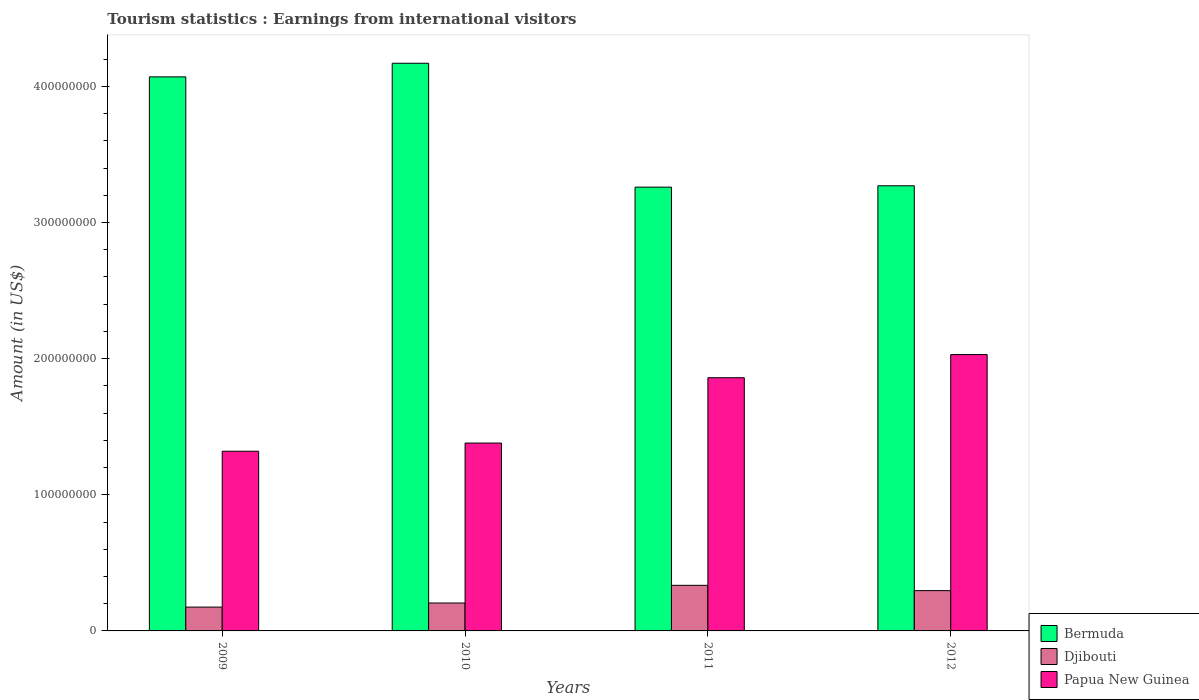How many groups of bars are there?
Provide a succinct answer. 4. Are the number of bars per tick equal to the number of legend labels?
Provide a succinct answer. Yes. Are the number of bars on each tick of the X-axis equal?
Your answer should be very brief. Yes. What is the label of the 4th group of bars from the left?
Offer a terse response. 2012. What is the earnings from international visitors in Papua New Guinea in 2011?
Provide a short and direct response. 1.86e+08. Across all years, what is the maximum earnings from international visitors in Bermuda?
Provide a short and direct response. 4.17e+08. Across all years, what is the minimum earnings from international visitors in Papua New Guinea?
Ensure brevity in your answer.  1.32e+08. In which year was the earnings from international visitors in Djibouti minimum?
Make the answer very short. 2009. What is the total earnings from international visitors in Bermuda in the graph?
Offer a very short reply. 1.48e+09. What is the difference between the earnings from international visitors in Papua New Guinea in 2011 and that in 2012?
Provide a short and direct response. -1.70e+07. What is the difference between the earnings from international visitors in Papua New Guinea in 2011 and the earnings from international visitors in Djibouti in 2010?
Keep it short and to the point. 1.66e+08. What is the average earnings from international visitors in Djibouti per year?
Give a very brief answer. 2.53e+07. In the year 2011, what is the difference between the earnings from international visitors in Papua New Guinea and earnings from international visitors in Djibouti?
Offer a very short reply. 1.52e+08. In how many years, is the earnings from international visitors in Bermuda greater than 40000000 US$?
Offer a very short reply. 4. What is the ratio of the earnings from international visitors in Bermuda in 2009 to that in 2010?
Provide a short and direct response. 0.98. Is the earnings from international visitors in Papua New Guinea in 2010 less than that in 2012?
Ensure brevity in your answer.  Yes. What is the difference between the highest and the second highest earnings from international visitors in Papua New Guinea?
Provide a succinct answer. 1.70e+07. What is the difference between the highest and the lowest earnings from international visitors in Bermuda?
Your answer should be very brief. 9.10e+07. In how many years, is the earnings from international visitors in Djibouti greater than the average earnings from international visitors in Djibouti taken over all years?
Offer a terse response. 2. What does the 1st bar from the left in 2010 represents?
Offer a very short reply. Bermuda. What does the 3rd bar from the right in 2009 represents?
Provide a succinct answer. Bermuda. Are all the bars in the graph horizontal?
Offer a terse response. No. Are the values on the major ticks of Y-axis written in scientific E-notation?
Offer a very short reply. No. Does the graph contain any zero values?
Your response must be concise. No. How many legend labels are there?
Your response must be concise. 3. How are the legend labels stacked?
Keep it short and to the point. Vertical. What is the title of the graph?
Your response must be concise. Tourism statistics : Earnings from international visitors. Does "Honduras" appear as one of the legend labels in the graph?
Ensure brevity in your answer.  No. What is the label or title of the X-axis?
Ensure brevity in your answer.  Years. What is the Amount (in US$) of Bermuda in 2009?
Keep it short and to the point. 4.07e+08. What is the Amount (in US$) in Djibouti in 2009?
Provide a short and direct response. 1.75e+07. What is the Amount (in US$) in Papua New Guinea in 2009?
Offer a terse response. 1.32e+08. What is the Amount (in US$) in Bermuda in 2010?
Your response must be concise. 4.17e+08. What is the Amount (in US$) of Djibouti in 2010?
Make the answer very short. 2.05e+07. What is the Amount (in US$) of Papua New Guinea in 2010?
Make the answer very short. 1.38e+08. What is the Amount (in US$) of Bermuda in 2011?
Ensure brevity in your answer.  3.26e+08. What is the Amount (in US$) in Djibouti in 2011?
Ensure brevity in your answer.  3.35e+07. What is the Amount (in US$) in Papua New Guinea in 2011?
Provide a short and direct response. 1.86e+08. What is the Amount (in US$) of Bermuda in 2012?
Make the answer very short. 3.27e+08. What is the Amount (in US$) of Djibouti in 2012?
Offer a very short reply. 2.96e+07. What is the Amount (in US$) in Papua New Guinea in 2012?
Ensure brevity in your answer.  2.03e+08. Across all years, what is the maximum Amount (in US$) of Bermuda?
Give a very brief answer. 4.17e+08. Across all years, what is the maximum Amount (in US$) of Djibouti?
Provide a succinct answer. 3.35e+07. Across all years, what is the maximum Amount (in US$) of Papua New Guinea?
Provide a short and direct response. 2.03e+08. Across all years, what is the minimum Amount (in US$) of Bermuda?
Ensure brevity in your answer.  3.26e+08. Across all years, what is the minimum Amount (in US$) of Djibouti?
Ensure brevity in your answer.  1.75e+07. Across all years, what is the minimum Amount (in US$) in Papua New Guinea?
Ensure brevity in your answer.  1.32e+08. What is the total Amount (in US$) in Bermuda in the graph?
Provide a succinct answer. 1.48e+09. What is the total Amount (in US$) in Djibouti in the graph?
Provide a succinct answer. 1.01e+08. What is the total Amount (in US$) in Papua New Guinea in the graph?
Make the answer very short. 6.59e+08. What is the difference between the Amount (in US$) in Bermuda in 2009 and that in 2010?
Make the answer very short. -1.00e+07. What is the difference between the Amount (in US$) in Papua New Guinea in 2009 and that in 2010?
Offer a very short reply. -6.00e+06. What is the difference between the Amount (in US$) in Bermuda in 2009 and that in 2011?
Provide a succinct answer. 8.10e+07. What is the difference between the Amount (in US$) in Djibouti in 2009 and that in 2011?
Offer a very short reply. -1.60e+07. What is the difference between the Amount (in US$) in Papua New Guinea in 2009 and that in 2011?
Make the answer very short. -5.40e+07. What is the difference between the Amount (in US$) of Bermuda in 2009 and that in 2012?
Provide a short and direct response. 8.00e+07. What is the difference between the Amount (in US$) of Djibouti in 2009 and that in 2012?
Provide a succinct answer. -1.21e+07. What is the difference between the Amount (in US$) in Papua New Guinea in 2009 and that in 2012?
Your answer should be compact. -7.10e+07. What is the difference between the Amount (in US$) in Bermuda in 2010 and that in 2011?
Keep it short and to the point. 9.10e+07. What is the difference between the Amount (in US$) in Djibouti in 2010 and that in 2011?
Your response must be concise. -1.30e+07. What is the difference between the Amount (in US$) in Papua New Guinea in 2010 and that in 2011?
Make the answer very short. -4.80e+07. What is the difference between the Amount (in US$) of Bermuda in 2010 and that in 2012?
Ensure brevity in your answer.  9.00e+07. What is the difference between the Amount (in US$) in Djibouti in 2010 and that in 2012?
Your answer should be very brief. -9.10e+06. What is the difference between the Amount (in US$) in Papua New Guinea in 2010 and that in 2012?
Offer a very short reply. -6.50e+07. What is the difference between the Amount (in US$) in Djibouti in 2011 and that in 2012?
Your answer should be very brief. 3.90e+06. What is the difference between the Amount (in US$) in Papua New Guinea in 2011 and that in 2012?
Keep it short and to the point. -1.70e+07. What is the difference between the Amount (in US$) in Bermuda in 2009 and the Amount (in US$) in Djibouti in 2010?
Provide a short and direct response. 3.86e+08. What is the difference between the Amount (in US$) of Bermuda in 2009 and the Amount (in US$) of Papua New Guinea in 2010?
Ensure brevity in your answer.  2.69e+08. What is the difference between the Amount (in US$) of Djibouti in 2009 and the Amount (in US$) of Papua New Guinea in 2010?
Your answer should be very brief. -1.20e+08. What is the difference between the Amount (in US$) of Bermuda in 2009 and the Amount (in US$) of Djibouti in 2011?
Give a very brief answer. 3.74e+08. What is the difference between the Amount (in US$) in Bermuda in 2009 and the Amount (in US$) in Papua New Guinea in 2011?
Your response must be concise. 2.21e+08. What is the difference between the Amount (in US$) in Djibouti in 2009 and the Amount (in US$) in Papua New Guinea in 2011?
Ensure brevity in your answer.  -1.68e+08. What is the difference between the Amount (in US$) of Bermuda in 2009 and the Amount (in US$) of Djibouti in 2012?
Provide a succinct answer. 3.77e+08. What is the difference between the Amount (in US$) of Bermuda in 2009 and the Amount (in US$) of Papua New Guinea in 2012?
Give a very brief answer. 2.04e+08. What is the difference between the Amount (in US$) of Djibouti in 2009 and the Amount (in US$) of Papua New Guinea in 2012?
Offer a terse response. -1.86e+08. What is the difference between the Amount (in US$) of Bermuda in 2010 and the Amount (in US$) of Djibouti in 2011?
Your answer should be very brief. 3.84e+08. What is the difference between the Amount (in US$) in Bermuda in 2010 and the Amount (in US$) in Papua New Guinea in 2011?
Ensure brevity in your answer.  2.31e+08. What is the difference between the Amount (in US$) of Djibouti in 2010 and the Amount (in US$) of Papua New Guinea in 2011?
Ensure brevity in your answer.  -1.66e+08. What is the difference between the Amount (in US$) in Bermuda in 2010 and the Amount (in US$) in Djibouti in 2012?
Offer a very short reply. 3.87e+08. What is the difference between the Amount (in US$) in Bermuda in 2010 and the Amount (in US$) in Papua New Guinea in 2012?
Make the answer very short. 2.14e+08. What is the difference between the Amount (in US$) in Djibouti in 2010 and the Amount (in US$) in Papua New Guinea in 2012?
Your answer should be compact. -1.82e+08. What is the difference between the Amount (in US$) of Bermuda in 2011 and the Amount (in US$) of Djibouti in 2012?
Ensure brevity in your answer.  2.96e+08. What is the difference between the Amount (in US$) of Bermuda in 2011 and the Amount (in US$) of Papua New Guinea in 2012?
Give a very brief answer. 1.23e+08. What is the difference between the Amount (in US$) of Djibouti in 2011 and the Amount (in US$) of Papua New Guinea in 2012?
Offer a very short reply. -1.70e+08. What is the average Amount (in US$) in Bermuda per year?
Your answer should be very brief. 3.69e+08. What is the average Amount (in US$) of Djibouti per year?
Offer a terse response. 2.53e+07. What is the average Amount (in US$) of Papua New Guinea per year?
Your response must be concise. 1.65e+08. In the year 2009, what is the difference between the Amount (in US$) of Bermuda and Amount (in US$) of Djibouti?
Provide a short and direct response. 3.90e+08. In the year 2009, what is the difference between the Amount (in US$) in Bermuda and Amount (in US$) in Papua New Guinea?
Ensure brevity in your answer.  2.75e+08. In the year 2009, what is the difference between the Amount (in US$) of Djibouti and Amount (in US$) of Papua New Guinea?
Your response must be concise. -1.14e+08. In the year 2010, what is the difference between the Amount (in US$) of Bermuda and Amount (in US$) of Djibouti?
Provide a succinct answer. 3.96e+08. In the year 2010, what is the difference between the Amount (in US$) in Bermuda and Amount (in US$) in Papua New Guinea?
Provide a succinct answer. 2.79e+08. In the year 2010, what is the difference between the Amount (in US$) in Djibouti and Amount (in US$) in Papua New Guinea?
Your response must be concise. -1.18e+08. In the year 2011, what is the difference between the Amount (in US$) in Bermuda and Amount (in US$) in Djibouti?
Your response must be concise. 2.92e+08. In the year 2011, what is the difference between the Amount (in US$) in Bermuda and Amount (in US$) in Papua New Guinea?
Make the answer very short. 1.40e+08. In the year 2011, what is the difference between the Amount (in US$) of Djibouti and Amount (in US$) of Papua New Guinea?
Keep it short and to the point. -1.52e+08. In the year 2012, what is the difference between the Amount (in US$) of Bermuda and Amount (in US$) of Djibouti?
Offer a terse response. 2.97e+08. In the year 2012, what is the difference between the Amount (in US$) of Bermuda and Amount (in US$) of Papua New Guinea?
Provide a short and direct response. 1.24e+08. In the year 2012, what is the difference between the Amount (in US$) in Djibouti and Amount (in US$) in Papua New Guinea?
Offer a terse response. -1.73e+08. What is the ratio of the Amount (in US$) in Bermuda in 2009 to that in 2010?
Make the answer very short. 0.98. What is the ratio of the Amount (in US$) of Djibouti in 2009 to that in 2010?
Your answer should be very brief. 0.85. What is the ratio of the Amount (in US$) of Papua New Guinea in 2009 to that in 2010?
Your answer should be compact. 0.96. What is the ratio of the Amount (in US$) of Bermuda in 2009 to that in 2011?
Provide a short and direct response. 1.25. What is the ratio of the Amount (in US$) in Djibouti in 2009 to that in 2011?
Keep it short and to the point. 0.52. What is the ratio of the Amount (in US$) in Papua New Guinea in 2009 to that in 2011?
Keep it short and to the point. 0.71. What is the ratio of the Amount (in US$) in Bermuda in 2009 to that in 2012?
Offer a very short reply. 1.24. What is the ratio of the Amount (in US$) of Djibouti in 2009 to that in 2012?
Your answer should be compact. 0.59. What is the ratio of the Amount (in US$) of Papua New Guinea in 2009 to that in 2012?
Provide a short and direct response. 0.65. What is the ratio of the Amount (in US$) of Bermuda in 2010 to that in 2011?
Provide a short and direct response. 1.28. What is the ratio of the Amount (in US$) of Djibouti in 2010 to that in 2011?
Give a very brief answer. 0.61. What is the ratio of the Amount (in US$) of Papua New Guinea in 2010 to that in 2011?
Your answer should be compact. 0.74. What is the ratio of the Amount (in US$) of Bermuda in 2010 to that in 2012?
Ensure brevity in your answer.  1.28. What is the ratio of the Amount (in US$) in Djibouti in 2010 to that in 2012?
Make the answer very short. 0.69. What is the ratio of the Amount (in US$) of Papua New Guinea in 2010 to that in 2012?
Your answer should be very brief. 0.68. What is the ratio of the Amount (in US$) in Bermuda in 2011 to that in 2012?
Your answer should be very brief. 1. What is the ratio of the Amount (in US$) of Djibouti in 2011 to that in 2012?
Ensure brevity in your answer.  1.13. What is the ratio of the Amount (in US$) of Papua New Guinea in 2011 to that in 2012?
Offer a very short reply. 0.92. What is the difference between the highest and the second highest Amount (in US$) of Djibouti?
Your answer should be compact. 3.90e+06. What is the difference between the highest and the second highest Amount (in US$) in Papua New Guinea?
Your answer should be very brief. 1.70e+07. What is the difference between the highest and the lowest Amount (in US$) of Bermuda?
Your answer should be compact. 9.10e+07. What is the difference between the highest and the lowest Amount (in US$) of Djibouti?
Ensure brevity in your answer.  1.60e+07. What is the difference between the highest and the lowest Amount (in US$) of Papua New Guinea?
Keep it short and to the point. 7.10e+07. 